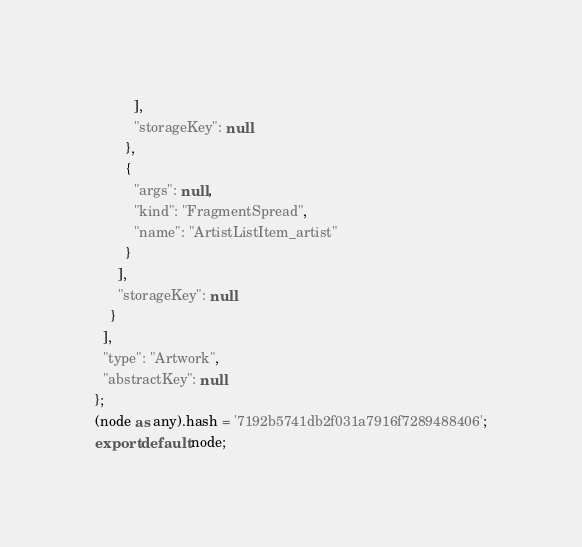Convert code to text. <code><loc_0><loc_0><loc_500><loc_500><_TypeScript_>          ],
          "storageKey": null
        },
        {
          "args": null,
          "kind": "FragmentSpread",
          "name": "ArtistListItem_artist"
        }
      ],
      "storageKey": null
    }
  ],
  "type": "Artwork",
  "abstractKey": null
};
(node as any).hash = '7192b5741db2f031a7916f7289488406';
export default node;
</code> 